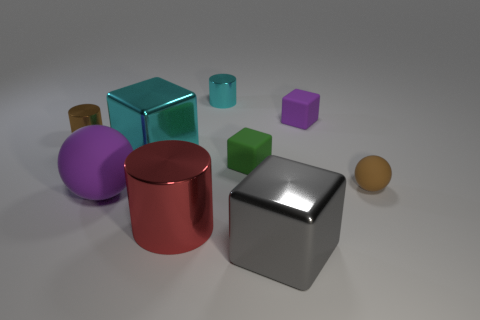What is the color of the cylinder in front of the small brown cylinder? The cylinder situated in front of the small brown cylinder has a vibrant red hue, providing a striking contrast against the surrounding objects. 